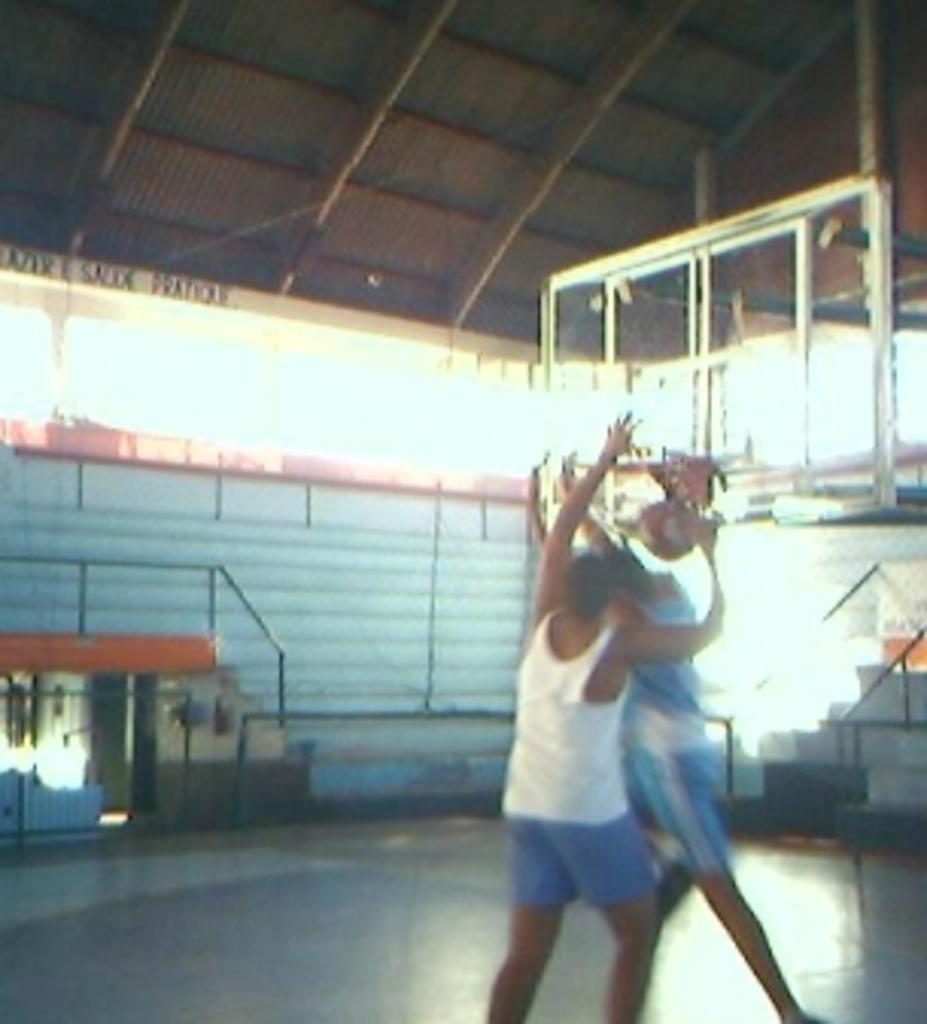Describe this image in one or two sentences. In this picture we can see two players playing basketball. On the right there is basketball net. In the background we can see staircase, railing, wall, windows and other objects. At the top there is roof. 